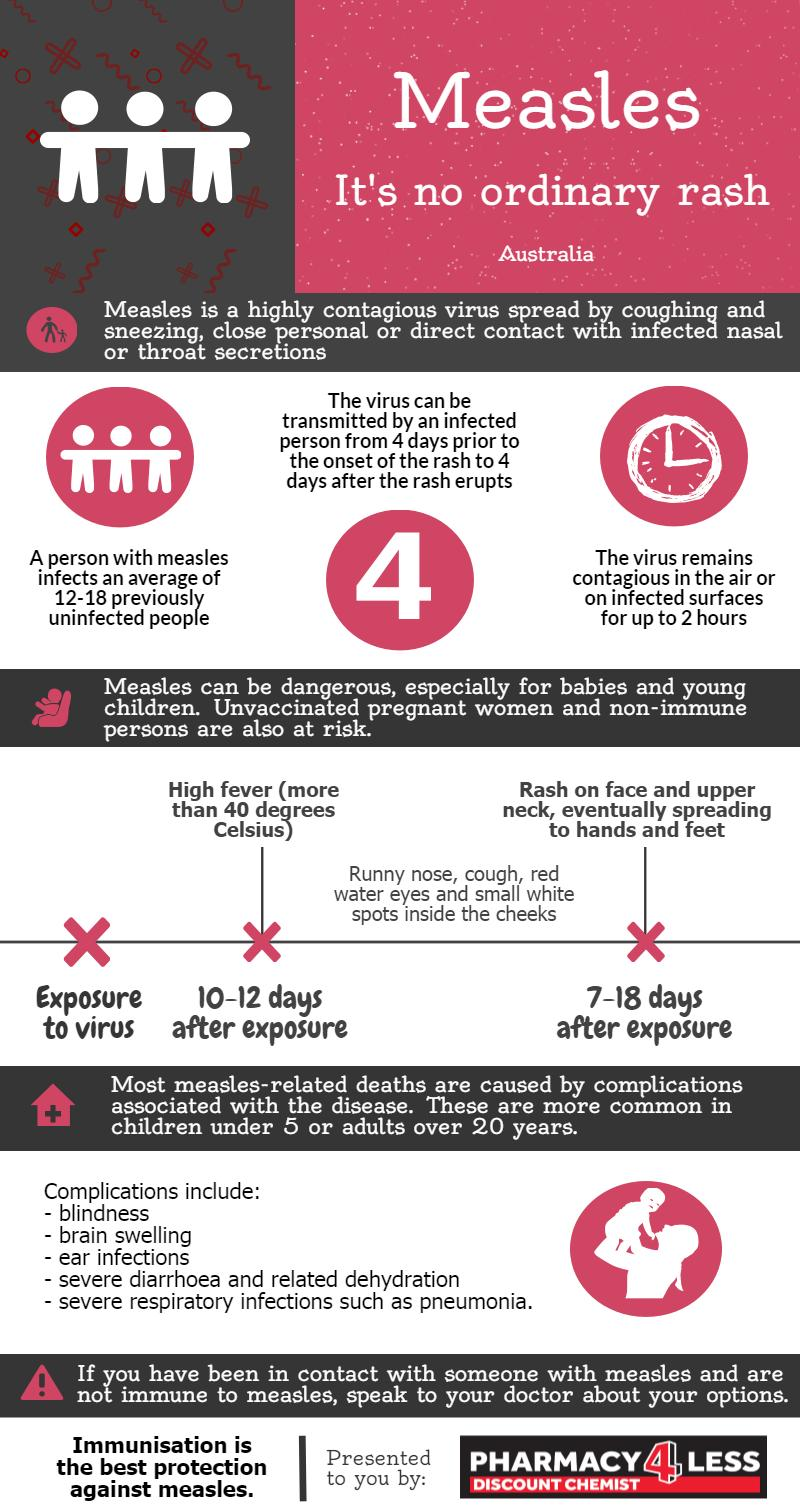Highlight a few significant elements in this photo. It is important for unvaccinated pregnant women and individuals with compromised immune systems to take extreme caution and ensure they receive the Measles vaccine to protect themselves against the disease. It is estimated that 12 to 18 individuals may contract measles from an infected person. The infographic lists severe diarrhoea and related dehydration as the fourth complication of measles, which can be life-threatening if not properly treated. The measles virus can remain in the air for up to 2 hours, according to research. Measles typically presents with a rash that appears on the face and neck 7-18 days after the virus has entered the body. 